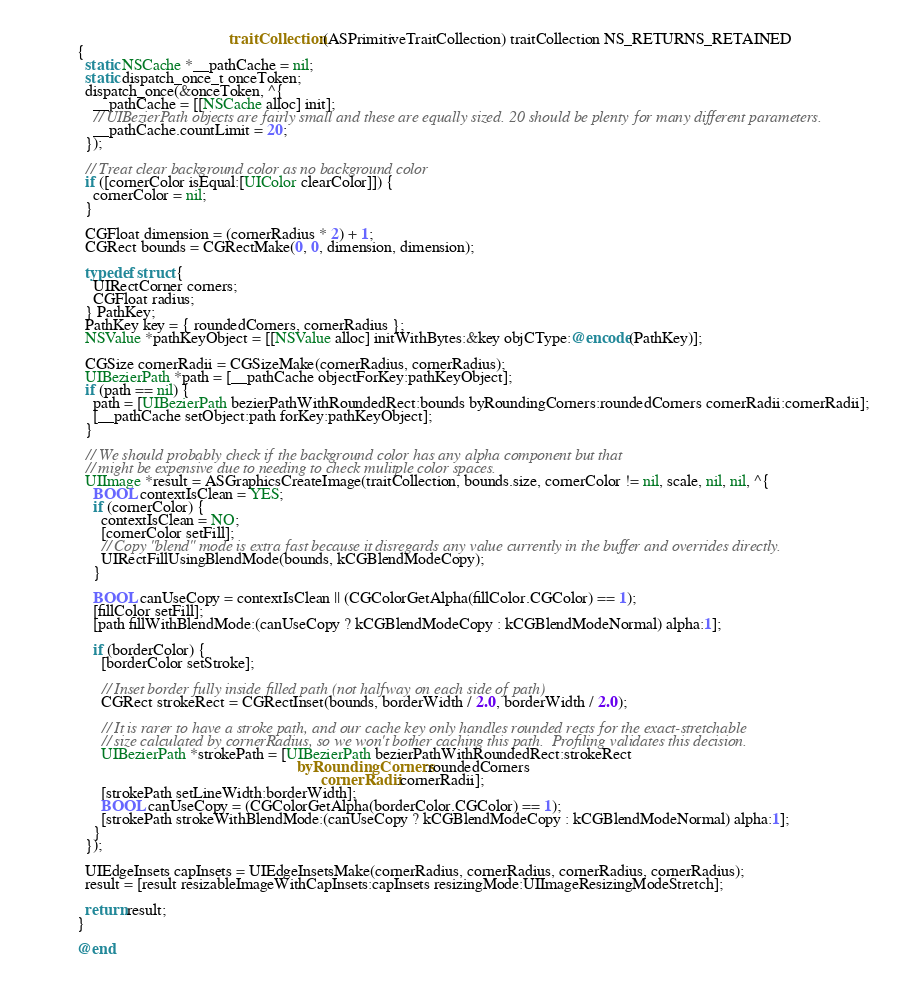<code> <loc_0><loc_0><loc_500><loc_500><_ObjectiveC_>                                      traitCollection:(ASPrimitiveTraitCollection) traitCollection NS_RETURNS_RETAINED
{
  static NSCache *__pathCache = nil;
  static dispatch_once_t onceToken;
  dispatch_once(&onceToken, ^{
    __pathCache = [[NSCache alloc] init];
    // UIBezierPath objects are fairly small and these are equally sized. 20 should be plenty for many different parameters.
    __pathCache.countLimit = 20;
  });
  
  // Treat clear background color as no background color
  if ([cornerColor isEqual:[UIColor clearColor]]) {
    cornerColor = nil;
  }
  
  CGFloat dimension = (cornerRadius * 2) + 1;
  CGRect bounds = CGRectMake(0, 0, dimension, dimension);
  
  typedef struct {
    UIRectCorner corners;
    CGFloat radius;
  } PathKey;
  PathKey key = { roundedCorners, cornerRadius };
  NSValue *pathKeyObject = [[NSValue alloc] initWithBytes:&key objCType:@encode(PathKey)];

  CGSize cornerRadii = CGSizeMake(cornerRadius, cornerRadius);
  UIBezierPath *path = [__pathCache objectForKey:pathKeyObject];
  if (path == nil) {
    path = [UIBezierPath bezierPathWithRoundedRect:bounds byRoundingCorners:roundedCorners cornerRadii:cornerRadii];
    [__pathCache setObject:path forKey:pathKeyObject];
  }
  
  // We should probably check if the background color has any alpha component but that
  // might be expensive due to needing to check mulitple color spaces.
  UIImage *result = ASGraphicsCreateImage(traitCollection, bounds.size, cornerColor != nil, scale, nil, nil, ^{
    BOOL contextIsClean = YES;
    if (cornerColor) {
      contextIsClean = NO;
      [cornerColor setFill];
      // Copy "blend" mode is extra fast because it disregards any value currently in the buffer and overrides directly.
      UIRectFillUsingBlendMode(bounds, kCGBlendModeCopy);
    }

    BOOL canUseCopy = contextIsClean || (CGColorGetAlpha(fillColor.CGColor) == 1);
    [fillColor setFill];
    [path fillWithBlendMode:(canUseCopy ? kCGBlendModeCopy : kCGBlendModeNormal) alpha:1];

    if (borderColor) {
      [borderColor setStroke];

      // Inset border fully inside filled path (not halfway on each side of path)
      CGRect strokeRect = CGRectInset(bounds, borderWidth / 2.0, borderWidth / 2.0);

      // It is rarer to have a stroke path, and our cache key only handles rounded rects for the exact-stretchable
      // size calculated by cornerRadius, so we won't bother caching this path.  Profiling validates this decision.
      UIBezierPath *strokePath = [UIBezierPath bezierPathWithRoundedRect:strokeRect
                                                       byRoundingCorners:roundedCorners
                                                             cornerRadii:cornerRadii];
      [strokePath setLineWidth:borderWidth];
      BOOL canUseCopy = (CGColorGetAlpha(borderColor.CGColor) == 1);
      [strokePath strokeWithBlendMode:(canUseCopy ? kCGBlendModeCopy : kCGBlendModeNormal) alpha:1];
    }
  });
  
  UIEdgeInsets capInsets = UIEdgeInsetsMake(cornerRadius, cornerRadius, cornerRadius, cornerRadius);
  result = [result resizableImageWithCapInsets:capInsets resizingMode:UIImageResizingModeStretch];
  
  return result;
}

@end
</code> 